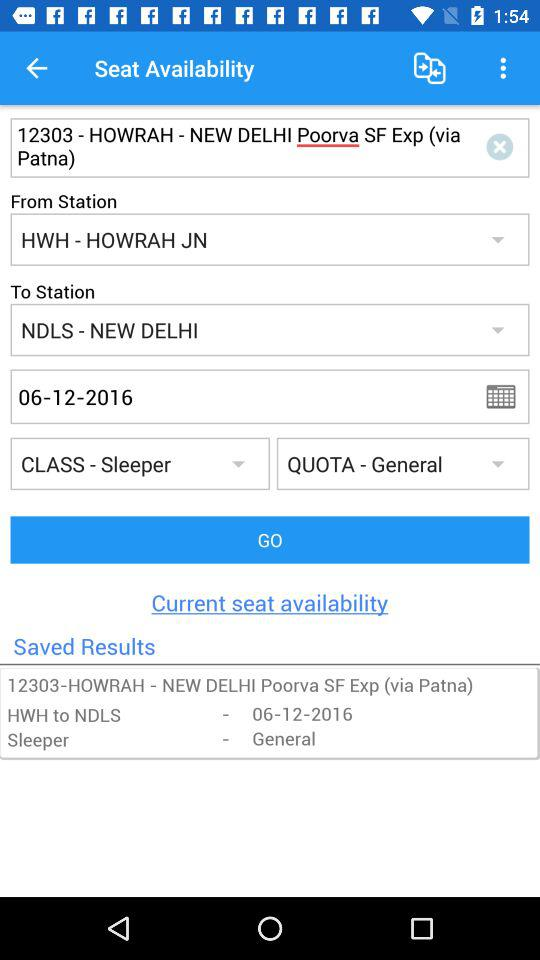What is the train name? The train name is Poorva Sf Exp (via Patna). 